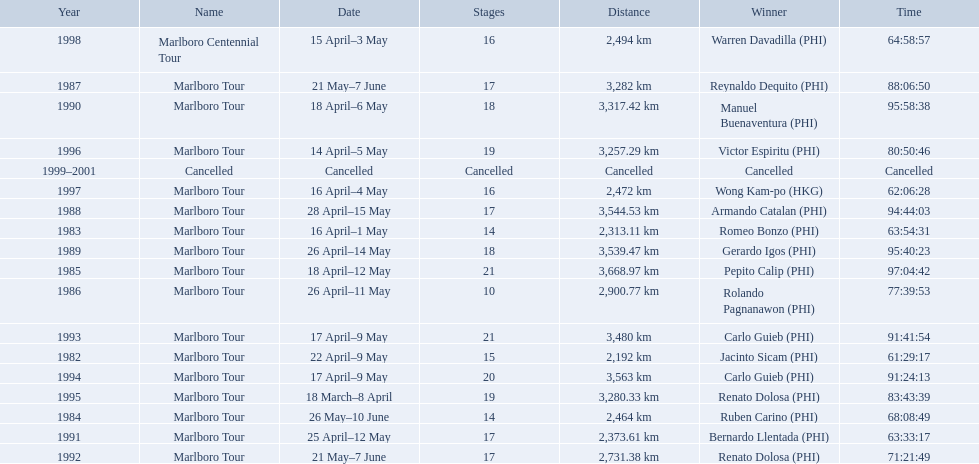What race did warren davadilla compete in in 1998? Marlboro Centennial Tour. How long did it take davadilla to complete the marlboro centennial tour? 64:58:57. What are the distances travelled on the tour? 2,192 km, 2,313.11 km, 2,464 km, 3,668.97 km, 2,900.77 km, 3,282 km, 3,544.53 km, 3,539.47 km, 3,317.42 km, 2,373.61 km, 2,731.38 km, 3,480 km, 3,563 km, 3,280.33 km, 3,257.29 km, 2,472 km, 2,494 km. Which of these are the largest? 3,668.97 km. 